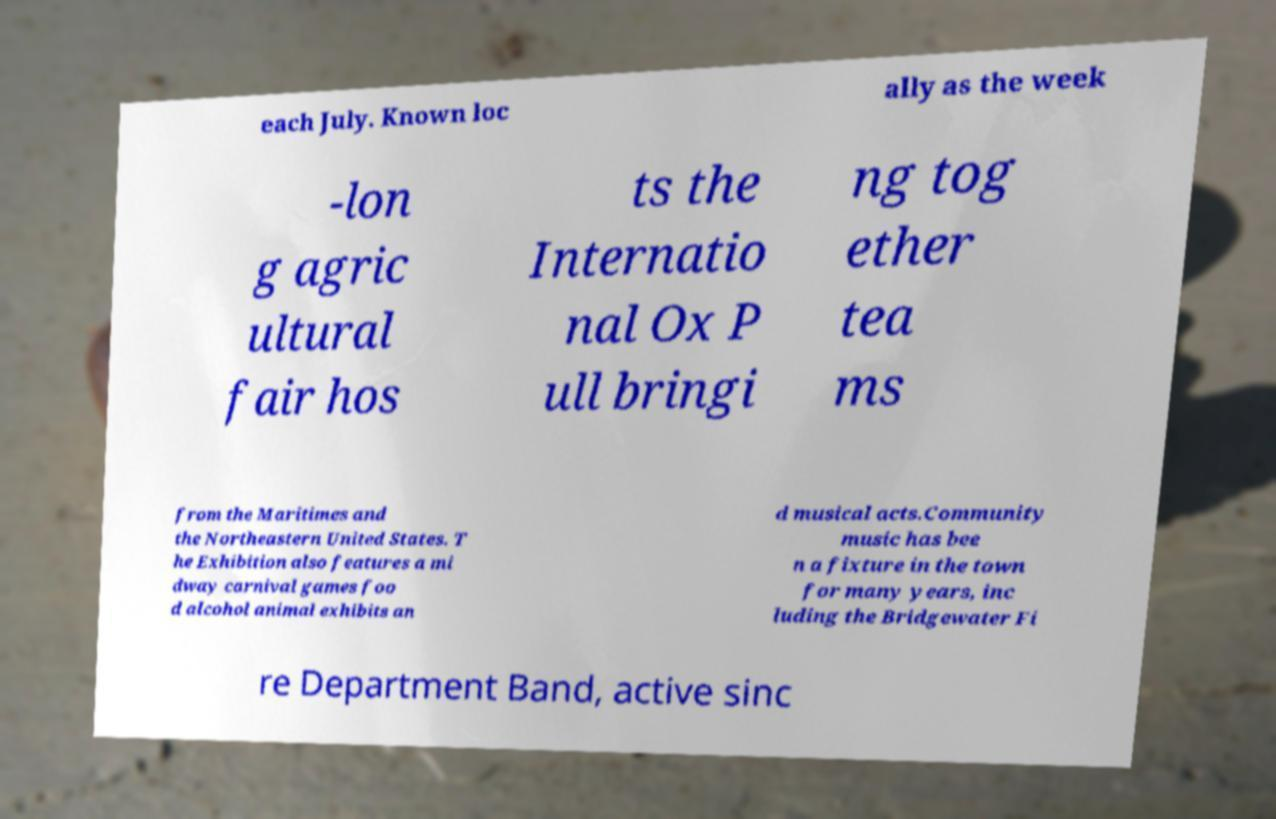For documentation purposes, I need the text within this image transcribed. Could you provide that? each July. Known loc ally as the week -lon g agric ultural fair hos ts the Internatio nal Ox P ull bringi ng tog ether tea ms from the Maritimes and the Northeastern United States. T he Exhibition also features a mi dway carnival games foo d alcohol animal exhibits an d musical acts.Community music has bee n a fixture in the town for many years, inc luding the Bridgewater Fi re Department Band, active sinc 